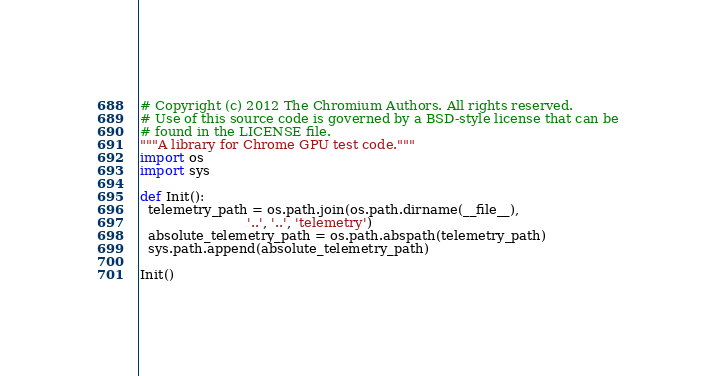Convert code to text. <code><loc_0><loc_0><loc_500><loc_500><_Python_># Copyright (c) 2012 The Chromium Authors. All rights reserved.
# Use of this source code is governed by a BSD-style license that can be
# found in the LICENSE file.
"""A library for Chrome GPU test code."""
import os
import sys

def Init():
  telemetry_path = os.path.join(os.path.dirname(__file__),
                          '..', '..', 'telemetry')
  absolute_telemetry_path = os.path.abspath(telemetry_path)
  sys.path.append(absolute_telemetry_path)

Init()
</code> 